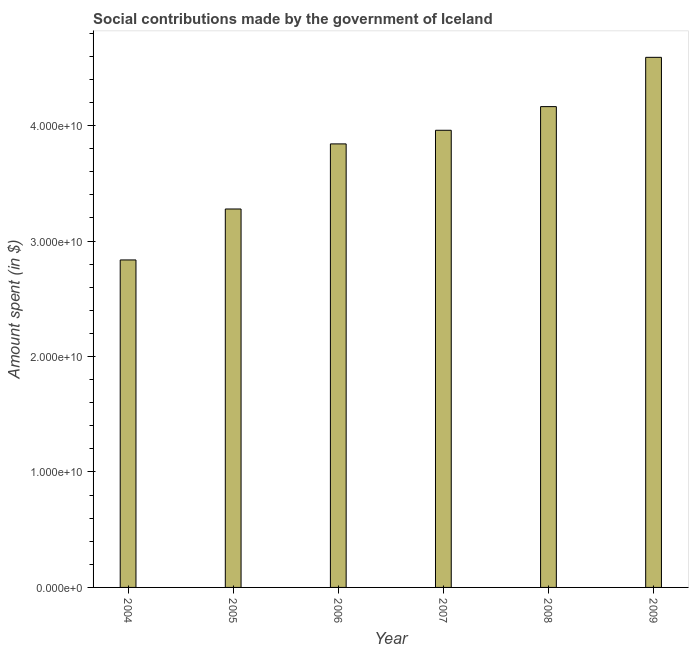Does the graph contain grids?
Make the answer very short. No. What is the title of the graph?
Offer a very short reply. Social contributions made by the government of Iceland. What is the label or title of the X-axis?
Make the answer very short. Year. What is the label or title of the Y-axis?
Offer a terse response. Amount spent (in $). What is the amount spent in making social contributions in 2007?
Your response must be concise. 3.96e+1. Across all years, what is the maximum amount spent in making social contributions?
Provide a short and direct response. 4.59e+1. Across all years, what is the minimum amount spent in making social contributions?
Give a very brief answer. 2.84e+1. In which year was the amount spent in making social contributions maximum?
Your answer should be compact. 2009. In which year was the amount spent in making social contributions minimum?
Your response must be concise. 2004. What is the sum of the amount spent in making social contributions?
Ensure brevity in your answer.  2.27e+11. What is the difference between the amount spent in making social contributions in 2004 and 2006?
Offer a terse response. -1.01e+1. What is the average amount spent in making social contributions per year?
Make the answer very short. 3.78e+1. What is the median amount spent in making social contributions?
Keep it short and to the point. 3.90e+1. Do a majority of the years between 2004 and 2005 (inclusive) have amount spent in making social contributions greater than 46000000000 $?
Ensure brevity in your answer.  No. What is the ratio of the amount spent in making social contributions in 2006 to that in 2009?
Provide a succinct answer. 0.84. Is the amount spent in making social contributions in 2006 less than that in 2007?
Your answer should be compact. Yes. Is the difference between the amount spent in making social contributions in 2005 and 2007 greater than the difference between any two years?
Offer a very short reply. No. What is the difference between the highest and the second highest amount spent in making social contributions?
Keep it short and to the point. 4.27e+09. What is the difference between the highest and the lowest amount spent in making social contributions?
Your answer should be compact. 1.75e+1. Are all the bars in the graph horizontal?
Your answer should be compact. No. How many years are there in the graph?
Your answer should be very brief. 6. What is the difference between two consecutive major ticks on the Y-axis?
Your answer should be compact. 1.00e+1. What is the Amount spent (in $) in 2004?
Provide a succinct answer. 2.84e+1. What is the Amount spent (in $) in 2005?
Offer a very short reply. 3.28e+1. What is the Amount spent (in $) of 2006?
Provide a short and direct response. 3.84e+1. What is the Amount spent (in $) in 2007?
Give a very brief answer. 3.96e+1. What is the Amount spent (in $) of 2008?
Keep it short and to the point. 4.16e+1. What is the Amount spent (in $) of 2009?
Your answer should be compact. 4.59e+1. What is the difference between the Amount spent (in $) in 2004 and 2005?
Provide a short and direct response. -4.41e+09. What is the difference between the Amount spent (in $) in 2004 and 2006?
Provide a short and direct response. -1.01e+1. What is the difference between the Amount spent (in $) in 2004 and 2007?
Your response must be concise. -1.12e+1. What is the difference between the Amount spent (in $) in 2004 and 2008?
Offer a terse response. -1.33e+1. What is the difference between the Amount spent (in $) in 2004 and 2009?
Offer a terse response. -1.75e+1. What is the difference between the Amount spent (in $) in 2005 and 2006?
Your answer should be very brief. -5.64e+09. What is the difference between the Amount spent (in $) in 2005 and 2007?
Ensure brevity in your answer.  -6.82e+09. What is the difference between the Amount spent (in $) in 2005 and 2008?
Give a very brief answer. -8.87e+09. What is the difference between the Amount spent (in $) in 2005 and 2009?
Give a very brief answer. -1.31e+1. What is the difference between the Amount spent (in $) in 2006 and 2007?
Provide a succinct answer. -1.18e+09. What is the difference between the Amount spent (in $) in 2006 and 2008?
Offer a terse response. -3.23e+09. What is the difference between the Amount spent (in $) in 2006 and 2009?
Make the answer very short. -7.50e+09. What is the difference between the Amount spent (in $) in 2007 and 2008?
Make the answer very short. -2.05e+09. What is the difference between the Amount spent (in $) in 2007 and 2009?
Provide a short and direct response. -6.32e+09. What is the difference between the Amount spent (in $) in 2008 and 2009?
Your response must be concise. -4.27e+09. What is the ratio of the Amount spent (in $) in 2004 to that in 2005?
Your answer should be very brief. 0.86. What is the ratio of the Amount spent (in $) in 2004 to that in 2006?
Make the answer very short. 0.74. What is the ratio of the Amount spent (in $) in 2004 to that in 2007?
Offer a terse response. 0.72. What is the ratio of the Amount spent (in $) in 2004 to that in 2008?
Ensure brevity in your answer.  0.68. What is the ratio of the Amount spent (in $) in 2004 to that in 2009?
Provide a succinct answer. 0.62. What is the ratio of the Amount spent (in $) in 2005 to that in 2006?
Keep it short and to the point. 0.85. What is the ratio of the Amount spent (in $) in 2005 to that in 2007?
Give a very brief answer. 0.83. What is the ratio of the Amount spent (in $) in 2005 to that in 2008?
Your answer should be very brief. 0.79. What is the ratio of the Amount spent (in $) in 2005 to that in 2009?
Keep it short and to the point. 0.71. What is the ratio of the Amount spent (in $) in 2006 to that in 2007?
Give a very brief answer. 0.97. What is the ratio of the Amount spent (in $) in 2006 to that in 2008?
Offer a terse response. 0.92. What is the ratio of the Amount spent (in $) in 2006 to that in 2009?
Your response must be concise. 0.84. What is the ratio of the Amount spent (in $) in 2007 to that in 2008?
Your answer should be compact. 0.95. What is the ratio of the Amount spent (in $) in 2007 to that in 2009?
Make the answer very short. 0.86. What is the ratio of the Amount spent (in $) in 2008 to that in 2009?
Your answer should be compact. 0.91. 